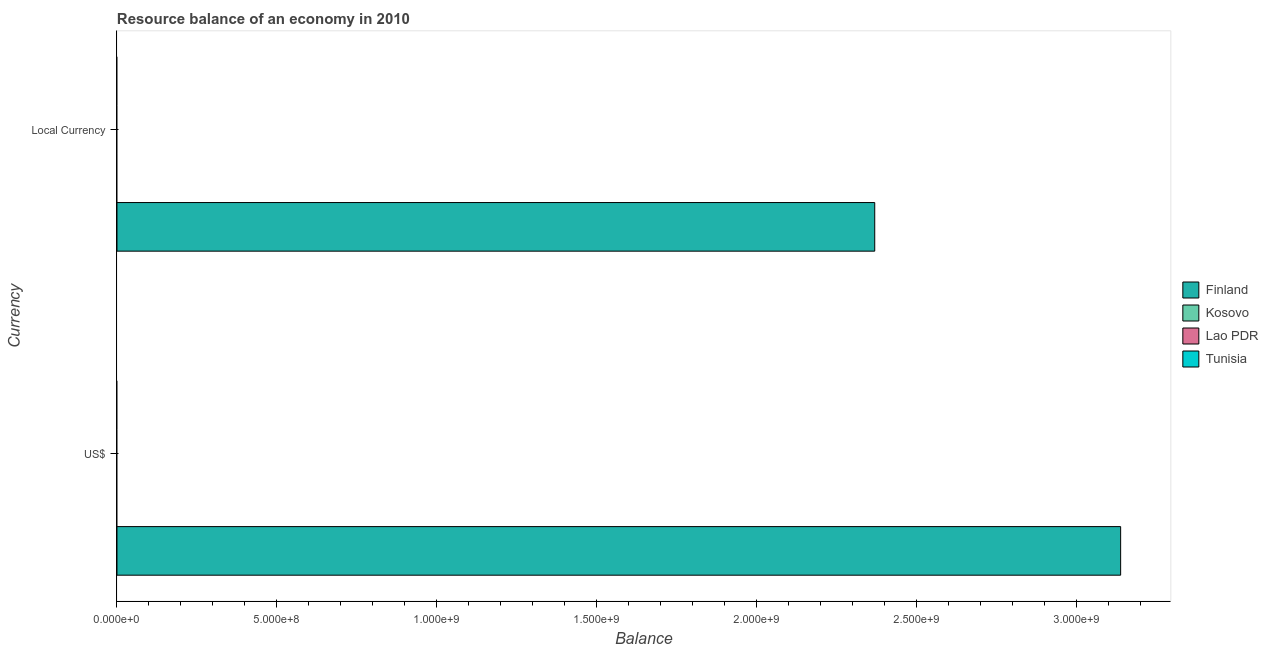How many different coloured bars are there?
Offer a very short reply. 1. How many bars are there on the 2nd tick from the bottom?
Your response must be concise. 1. What is the label of the 1st group of bars from the top?
Your response must be concise. Local Currency. Across all countries, what is the maximum resource balance in constant us$?
Your response must be concise. 2.37e+09. What is the total resource balance in constant us$ in the graph?
Offer a terse response. 2.37e+09. What is the difference between the resource balance in us$ in Finland and the resource balance in constant us$ in Tunisia?
Ensure brevity in your answer.  3.14e+09. What is the average resource balance in constant us$ per country?
Provide a succinct answer. 5.92e+08. What is the difference between the resource balance in constant us$ and resource balance in us$ in Finland?
Give a very brief answer. -7.68e+08. In how many countries, is the resource balance in constant us$ greater than 1100000000 units?
Give a very brief answer. 1. What is the difference between two consecutive major ticks on the X-axis?
Provide a short and direct response. 5.00e+08. Are the values on the major ticks of X-axis written in scientific E-notation?
Your answer should be very brief. Yes. How many legend labels are there?
Provide a short and direct response. 4. How are the legend labels stacked?
Your response must be concise. Vertical. What is the title of the graph?
Your response must be concise. Resource balance of an economy in 2010. What is the label or title of the X-axis?
Offer a terse response. Balance. What is the label or title of the Y-axis?
Give a very brief answer. Currency. What is the Balance in Finland in US$?
Give a very brief answer. 3.14e+09. What is the Balance in Finland in Local Currency?
Provide a succinct answer. 2.37e+09. What is the Balance in Kosovo in Local Currency?
Your response must be concise. 0. What is the Balance in Lao PDR in Local Currency?
Make the answer very short. 0. Across all Currency, what is the maximum Balance in Finland?
Offer a terse response. 3.14e+09. Across all Currency, what is the minimum Balance in Finland?
Give a very brief answer. 2.37e+09. What is the total Balance in Finland in the graph?
Your answer should be compact. 5.50e+09. What is the total Balance in Tunisia in the graph?
Offer a terse response. 0. What is the difference between the Balance of Finland in US$ and that in Local Currency?
Keep it short and to the point. 7.68e+08. What is the average Balance of Finland per Currency?
Provide a succinct answer. 2.75e+09. What is the average Balance of Lao PDR per Currency?
Make the answer very short. 0. What is the ratio of the Balance of Finland in US$ to that in Local Currency?
Make the answer very short. 1.32. What is the difference between the highest and the second highest Balance in Finland?
Your answer should be very brief. 7.68e+08. What is the difference between the highest and the lowest Balance of Finland?
Your response must be concise. 7.68e+08. 